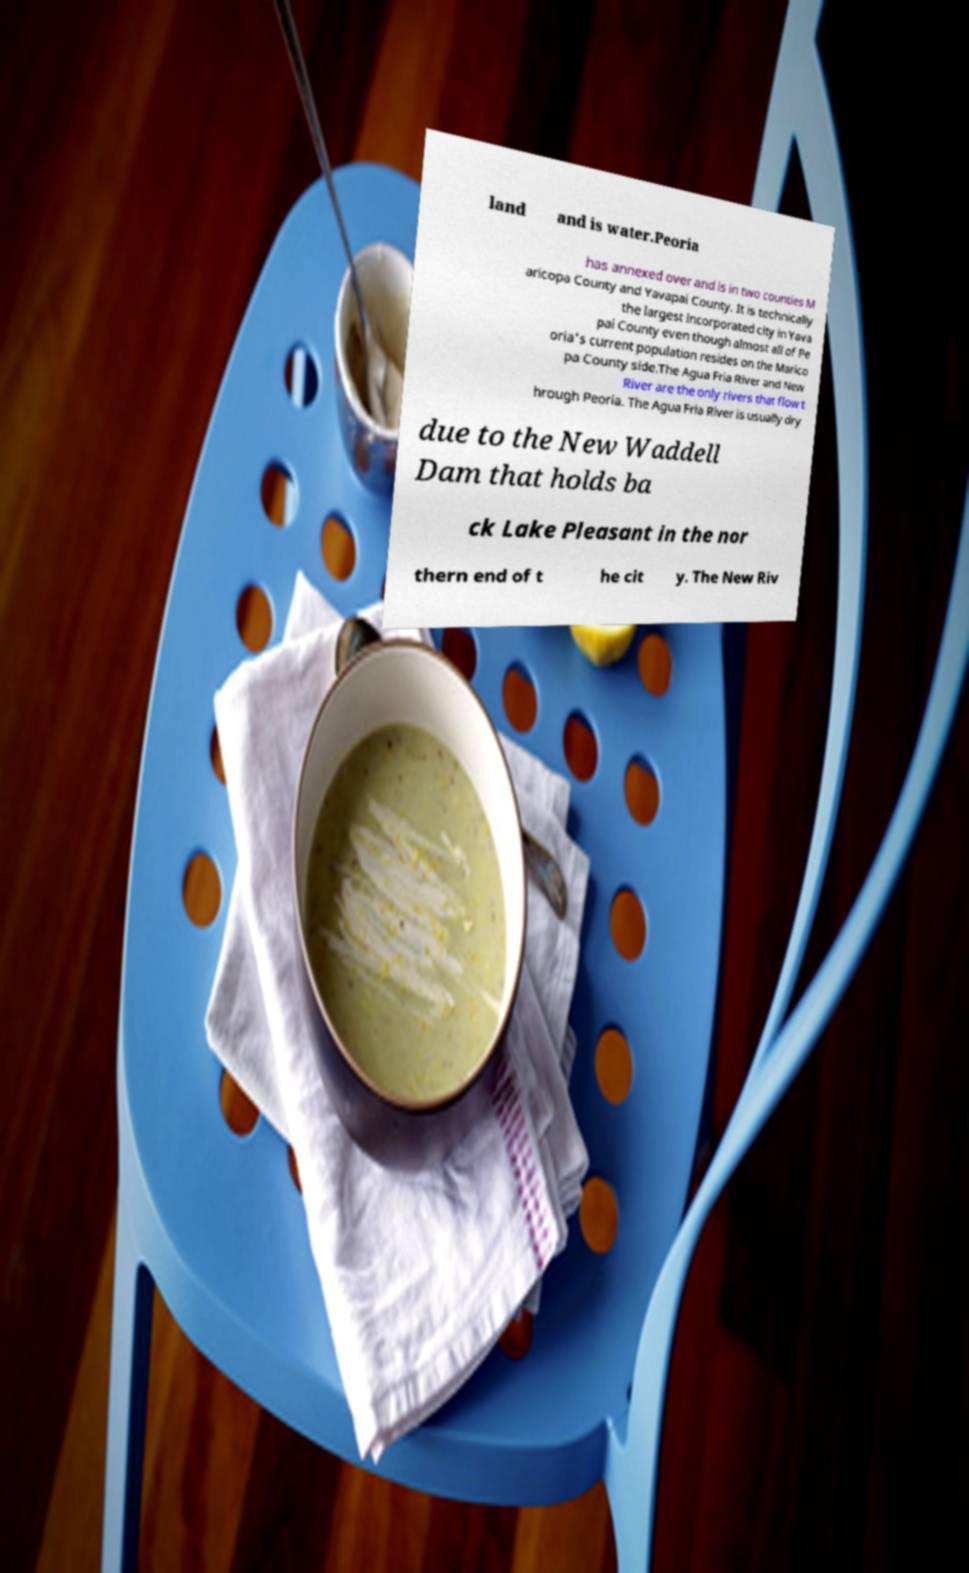I need the written content from this picture converted into text. Can you do that? land and is water.Peoria has annexed over and is in two counties M aricopa County and Yavapai County. It is technically the largest incorporated city in Yava pai County even though almost all of Pe oria's current population resides on the Marico pa County side.The Agua Fria River and New River are the only rivers that flow t hrough Peoria. The Agua Fria River is usually dry due to the New Waddell Dam that holds ba ck Lake Pleasant in the nor thern end of t he cit y. The New Riv 